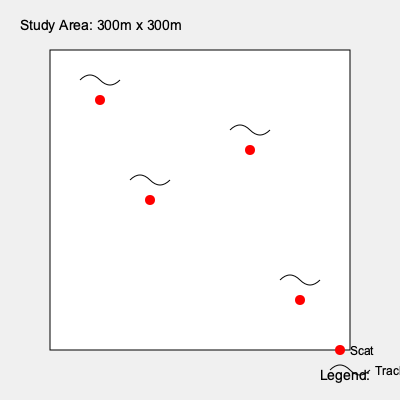Based on the animal signs (scat and tracks) observed in the 300m x 300m study area, estimate the population density of the species per square kilometer. Assume each set of signs represents one individual animal. To estimate the population density, we'll follow these steps:

1. Count the number of individual animals:
   - Each set of scat and tracks represents one animal
   - There are 4 sets of signs visible in the study area
   - Therefore, we estimate 4 individuals in the area

2. Calculate the study area size:
   - The study area is 300m x 300m
   - Area = 300m × 300m = 90,000 m²

3. Convert the study area to square kilometers:
   - 1 km² = 1,000,000 m²
   - Study area in km² = 90,000 m² ÷ 1,000,000 m²/km² = 0.09 km²

4. Calculate the population density:
   - Density = Number of individuals ÷ Area
   - Density = 4 individuals ÷ 0.09 km²
   - Density = 44.44 individuals/km²

5. Round to the nearest whole number:
   - Estimated population density ≈ 44 individuals/km²
Answer: 44 individuals/km² 